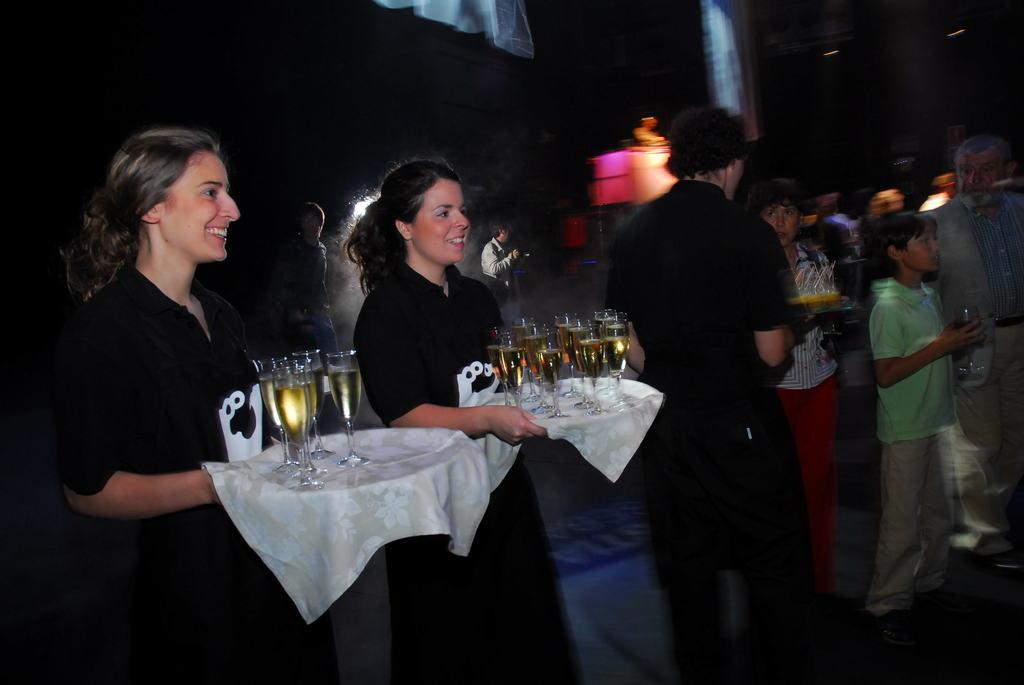How many women are in the foreground of the image? There are two women in the foreground of the image. What are the women doing in the image? The women are standing and holding a plate of glasses. What can be seen in the background of the image? There is a crowd in the background of the image. How would you describe the lighting in the top part of the image? The top part of the image is dark. What type of cactus can be seen in the image? There is no cactus present in the image. How does the lawyer assist the women in the image? There is no lawyer present in the image, so it is not possible to determine how they might assist the women. 